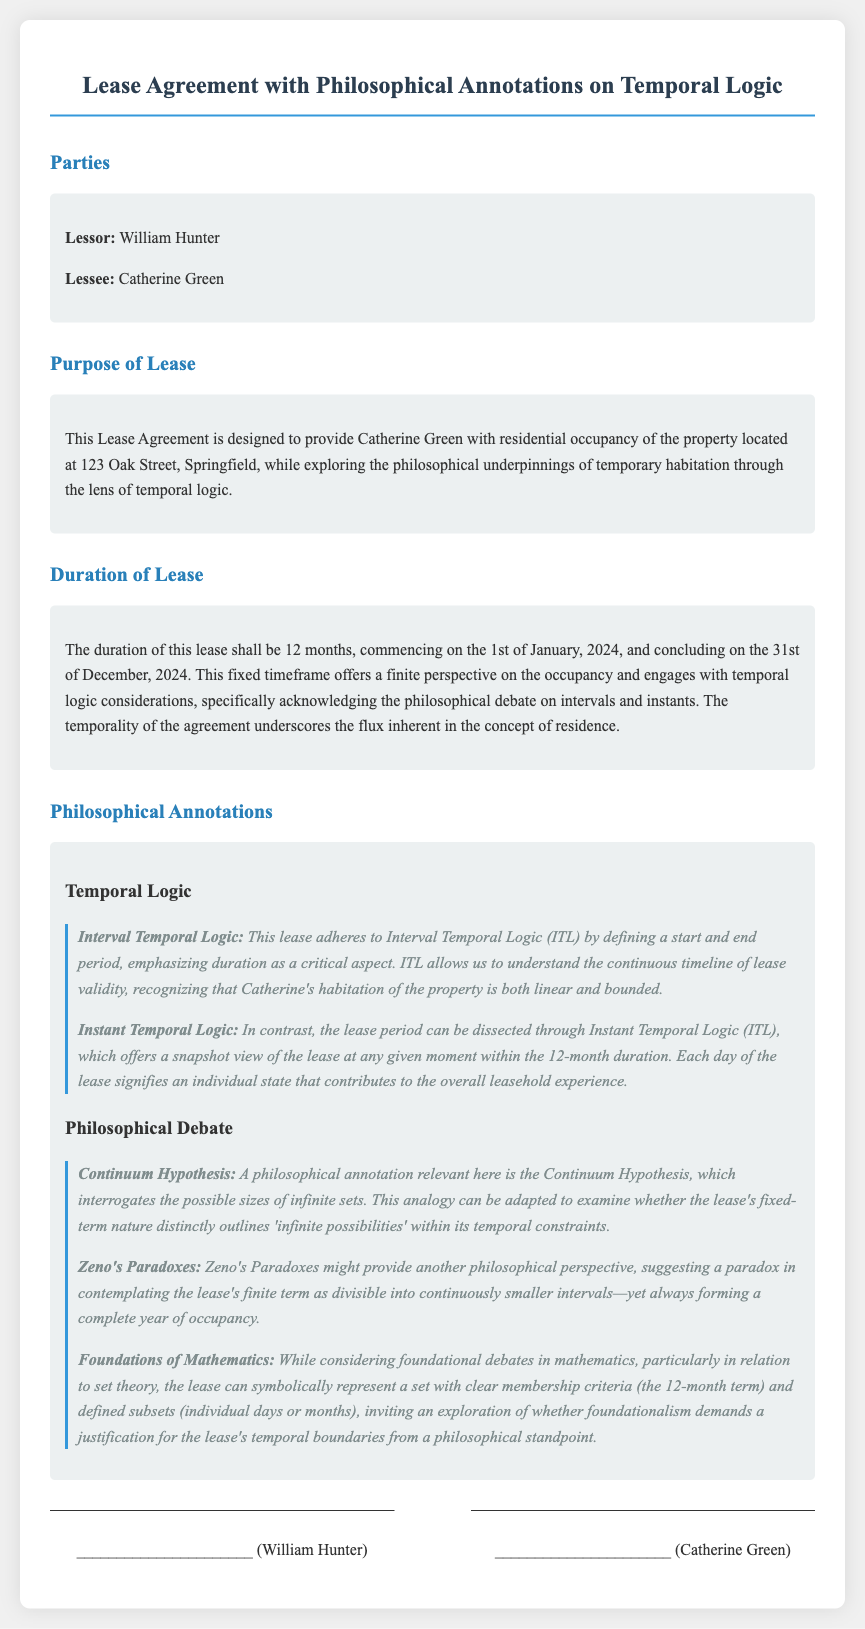What is the name of the lessor? The lessor's name is explicitly stated in the document as William Hunter.
Answer: William Hunter What is the address of the leased property? The document specifies the address of the property as 123 Oak Street, Springfield.
Answer: 123 Oak Street, Springfield What is the duration of the lease? The duration of the lease is clearly stated as 12 months in the document.
Answer: 12 months When does the lease commence? The start date of the lease is noted as the 1st of January, 2024.
Answer: 1st of January, 2024 What philosophical concept is emphasized in relation to the lease duration? The lease duration engages with the philosophical concept of temporal logic, specifically relating to intervals and instants.
Answer: Temporal logic Which paradoxes are mentioned in the document? The document references Zeno's Paradoxes within the philosophical annotations.
Answer: Zeno's Paradoxes What theory is interrogated in relation to the lease's nature? The Continuum Hypothesis is discussed as relevant to understanding the lease's fixed-term nature.
Answer: Continuum Hypothesis What is the concluding date of the lease? The lease concludes on the 31st of December, 2024, as specified in the agreement.
Answer: 31st of December, 2024 Who is the lessee? The agreement lists Catherine Green as the lessee.
Answer: Catherine Green 